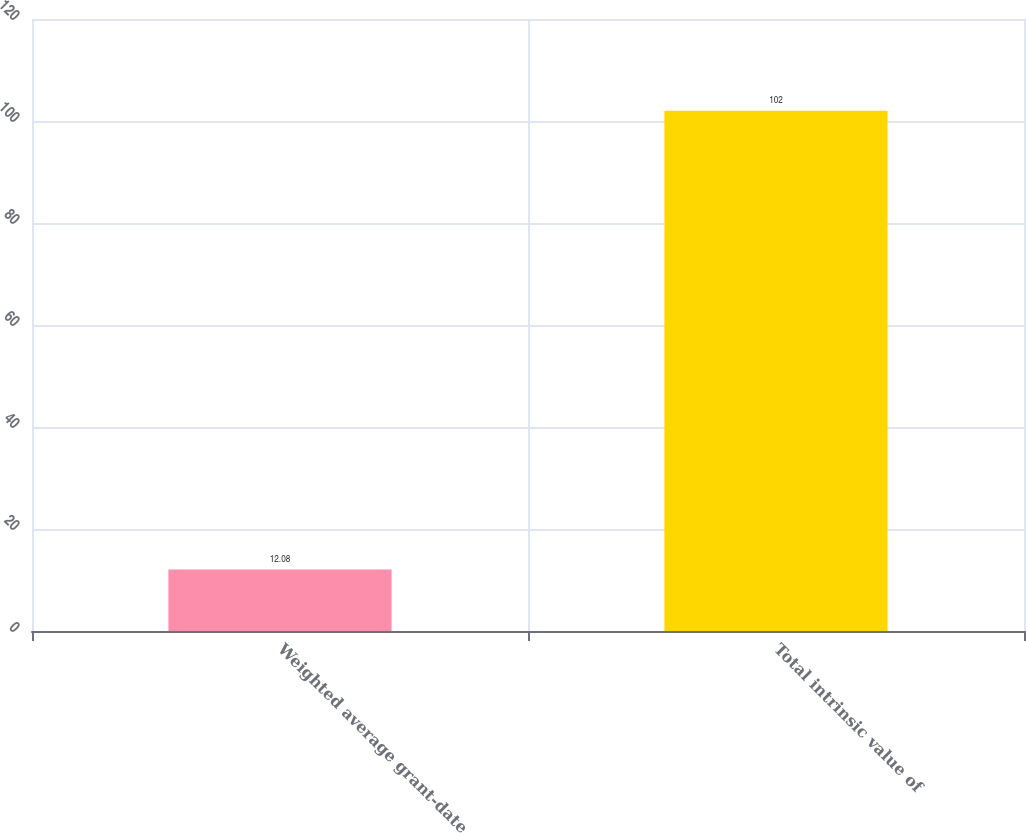Convert chart. <chart><loc_0><loc_0><loc_500><loc_500><bar_chart><fcel>Weighted average grant-date<fcel>Total intrinsic value of<nl><fcel>12.08<fcel>102<nl></chart> 